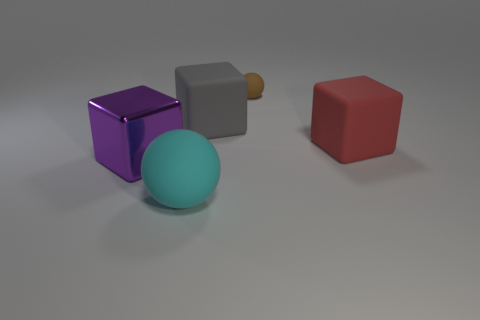Is there any other thing that is the same material as the large purple cube?
Provide a short and direct response. No. Are there any other big things of the same shape as the metal object?
Offer a very short reply. Yes. What number of things are large rubber objects in front of the red thing or balls?
Offer a very short reply. 2. The brown rubber object is what size?
Ensure brevity in your answer.  Small. How many big objects are either matte blocks or shiny cubes?
Ensure brevity in your answer.  3. What is the color of the shiny block that is the same size as the gray rubber cube?
Your answer should be very brief. Purple. What number of other objects are there of the same shape as the purple metal thing?
Make the answer very short. 2. Are there any purple objects that have the same material as the large cyan sphere?
Your answer should be very brief. No. Do the ball that is in front of the gray matte block and the sphere that is right of the big cyan object have the same material?
Offer a terse response. Yes. What number of large matte things are there?
Offer a very short reply. 3. 